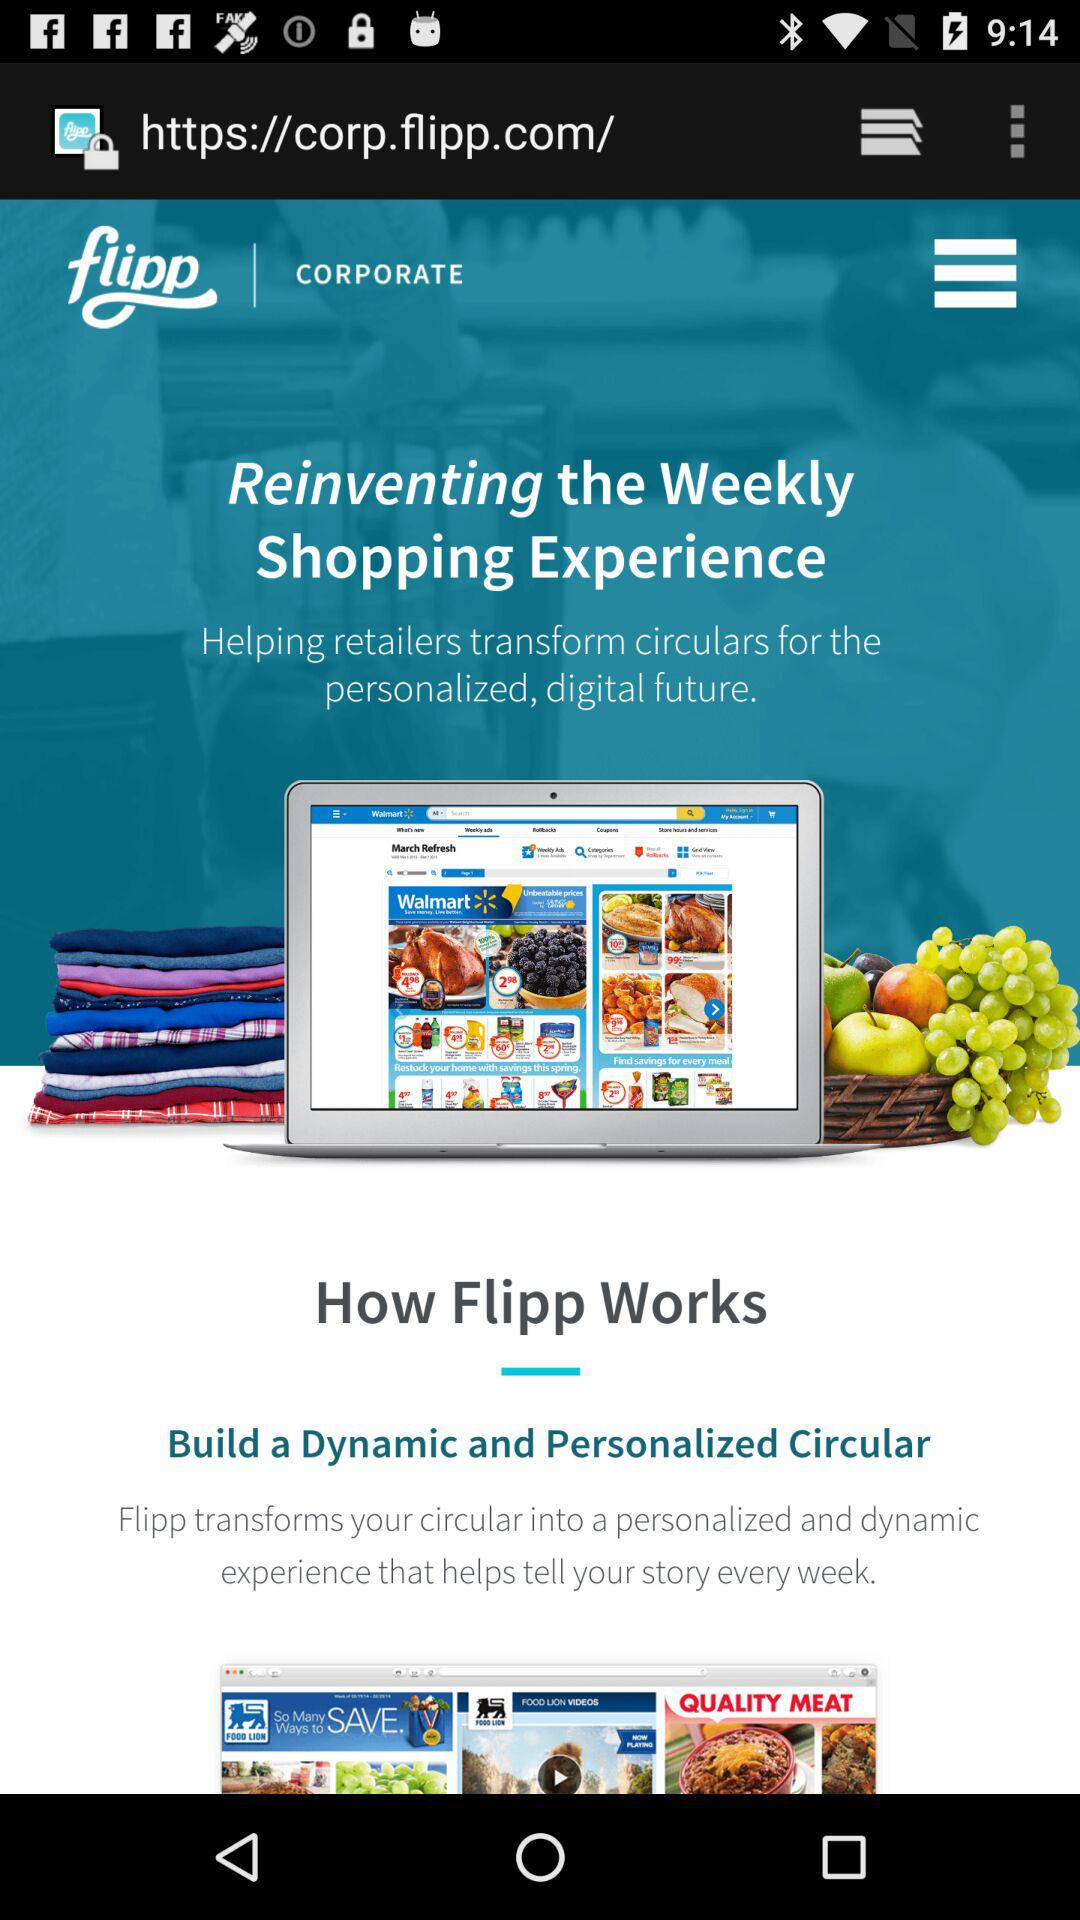What is the name of the application? The name of the application is "Flipp". 